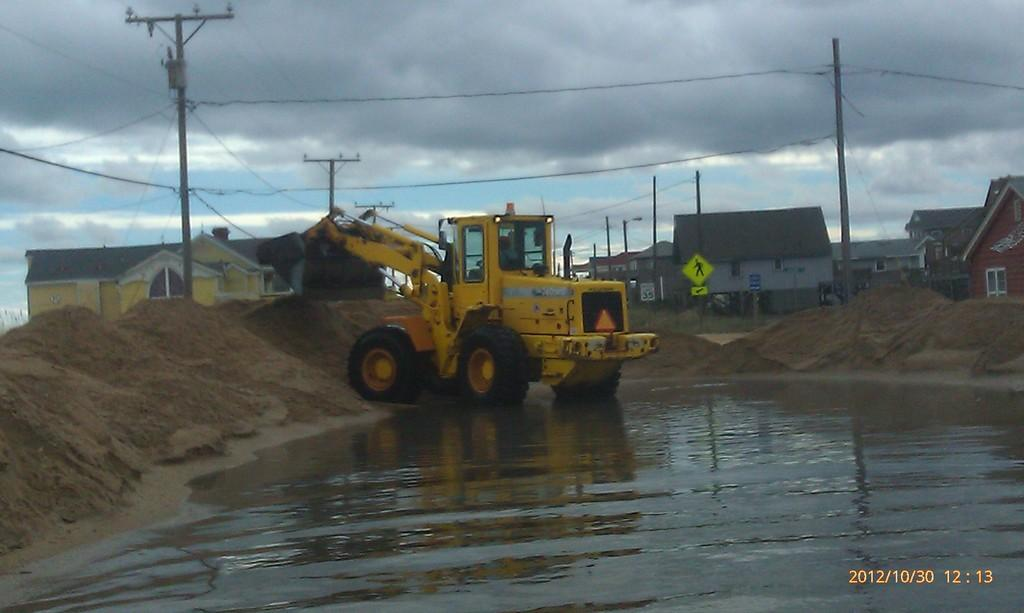<image>
Give a short and clear explanation of the subsequent image. A photo of a tractor that was taken on October 30 of 2012. 